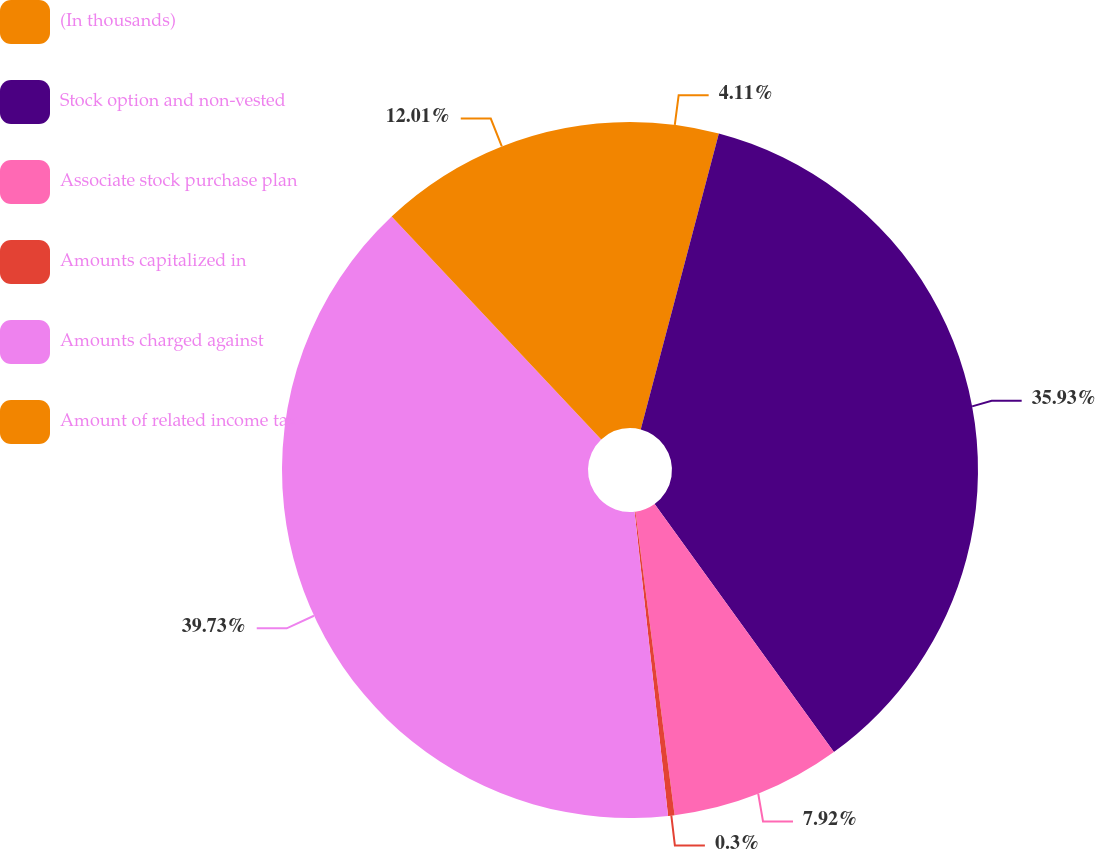<chart> <loc_0><loc_0><loc_500><loc_500><pie_chart><fcel>(In thousands)<fcel>Stock option and non-vested<fcel>Associate stock purchase plan<fcel>Amounts capitalized in<fcel>Amounts charged against<fcel>Amount of related income tax<nl><fcel>4.11%<fcel>35.93%<fcel>7.92%<fcel>0.3%<fcel>39.74%<fcel>12.01%<nl></chart> 